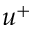Convert formula to latex. <formula><loc_0><loc_0><loc_500><loc_500>u ^ { + }</formula> 